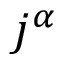Convert formula to latex. <formula><loc_0><loc_0><loc_500><loc_500>j ^ { \alpha }</formula> 